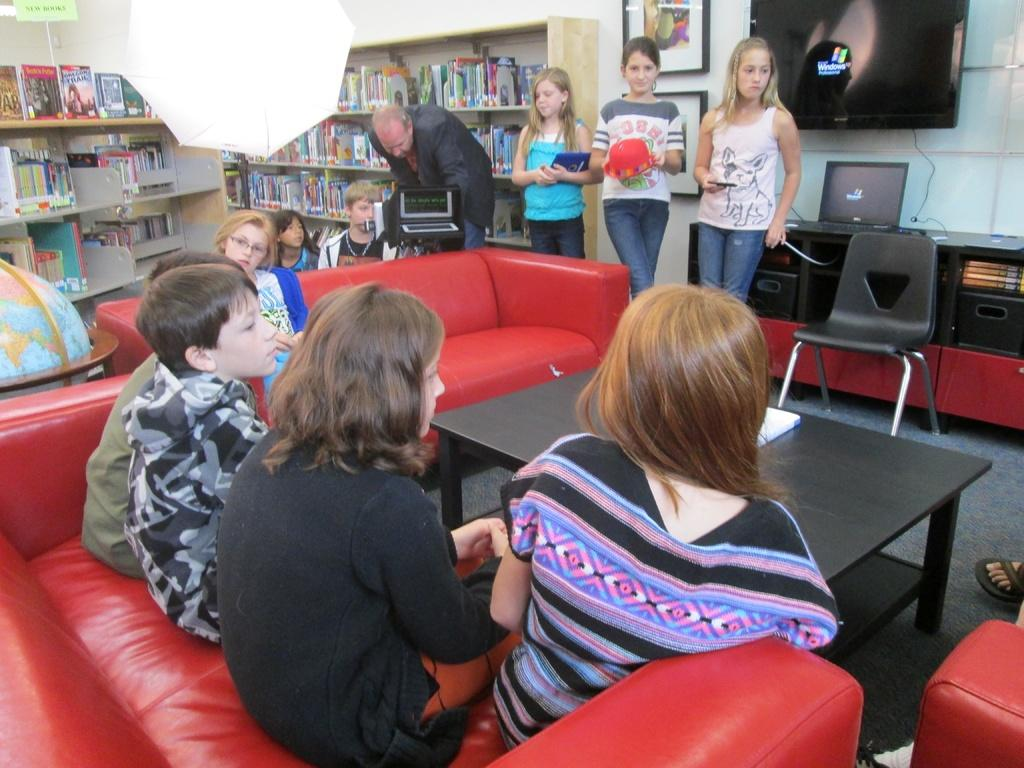<image>
Describe the image concisely. The windows logo is displayed on the screen on the wall while many people sit and stand around. 